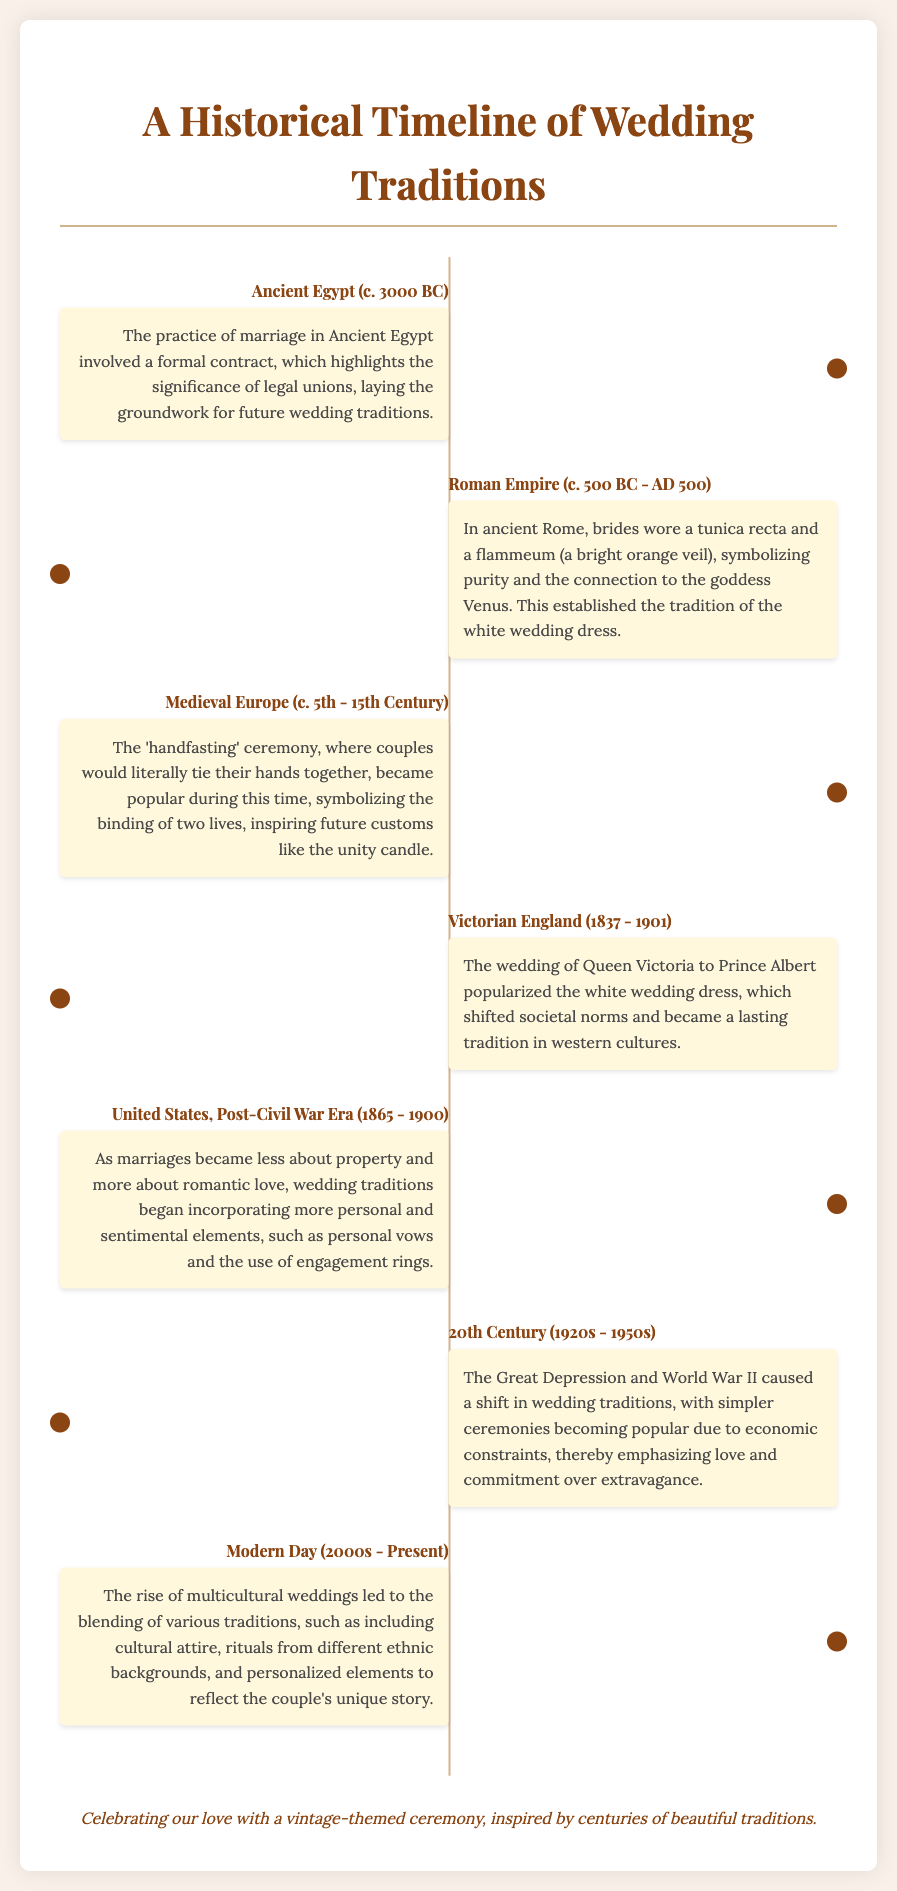What era did the 'handfasting' ceremony become popular? The 'handfasting' ceremony became popular in Medieval Europe, which spans from the 5th to the 15th century.
Answer: Medieval Europe (c. 5th - 15th Century) Who popularized the white wedding dress? The wedding of Queen Victoria to Prince Albert popularized the white wedding dress, establishing it as a tradition.
Answer: Queen Victoria What were couples' hands tied together during the 'handfasting' ceremony meant to symbolize? The tying of hands during the 'handfasting' ceremony symbolized the binding of two lives together.
Answer: Binding of two lives When did the Great Depression influence wedding traditions? The Great Depression influenced wedding traditions during the 20th Century, particularly in the 1920s to 1950s.
Answer: 1920s - 1950s What shift occurred in wedding traditions post-Civil War Era in the United States? Post-Civil War Era, weddings shifted from being about property to being about romantic love.
Answer: Romantic love What colors did brides traditionally wear in ancient Rome? In ancient Rome, brides traditionally wore a tunica recta and a flammeum, a bright orange veil.
Answer: Bright orange What element was increasingly incorporated into weddings in the Post-Civil War Era? Personal vows became a more common element in weddings during the Post-Civil War Era.
Answer: Personal vows What societal change did the wedding of Queen Victoria represent? Queen Victoria's wedding represented a societal shift toward the acceptance of white wedding dresses as a norm in Western cultures.
Answer: Shift in societal norms 